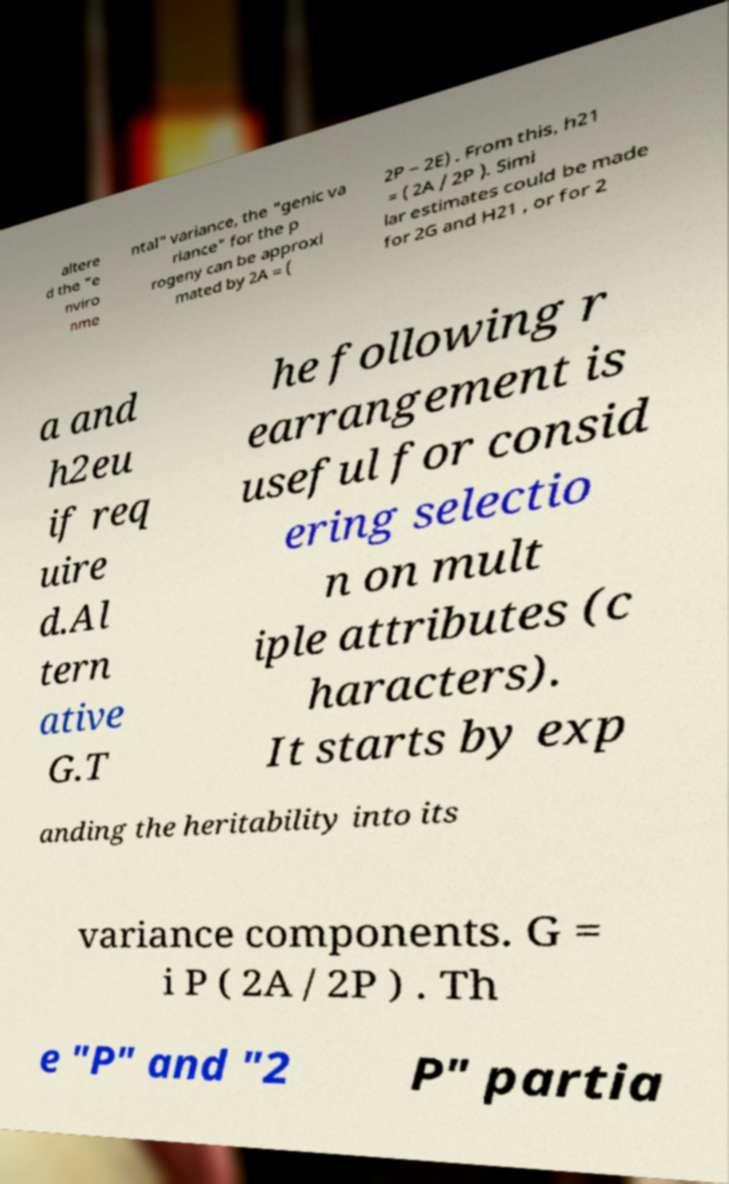Could you assist in decoding the text presented in this image and type it out clearly? altere d the "e nviro nme ntal" variance, the "genic va riance" for the p rogeny can be approxi mated by 2A = ( 2P − 2E) . From this, h21 = ( 2A / 2P ). Simi lar estimates could be made for 2G and H21 , or for 2 a and h2eu if req uire d.Al tern ative G.T he following r earrangement is useful for consid ering selectio n on mult iple attributes (c haracters). It starts by exp anding the heritability into its variance components. G = i P ( 2A / 2P ) . Th e "P" and "2 P" partia 